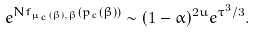<formula> <loc_0><loc_0><loc_500><loc_500>e ^ { N f _ { \mu _ { c } ( \beta ) , \beta } ( p _ { c } ( \beta ) ) } \sim ( 1 - \alpha ) ^ { 2 u } e ^ { \tau ^ { 3 } / 3 } .</formula> 